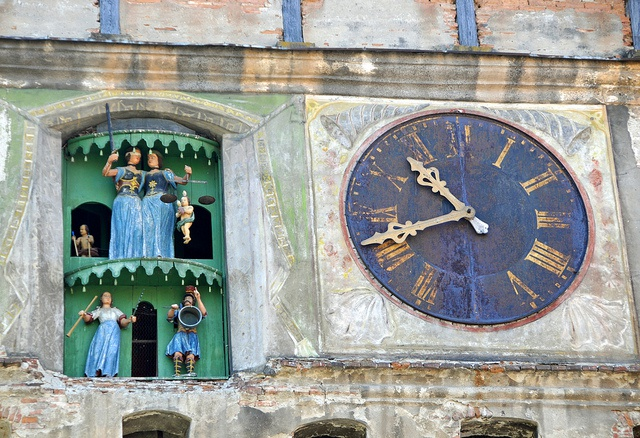Describe the objects in this image and their specific colors. I can see clock in darkgray, gray, tan, and darkblue tones, people in darkgray, lightblue, gray, and black tones, people in darkgray, black, lightblue, teal, and gray tones, people in darkgray, tan, beige, and gray tones, and people in darkgray, black, tan, and gray tones in this image. 